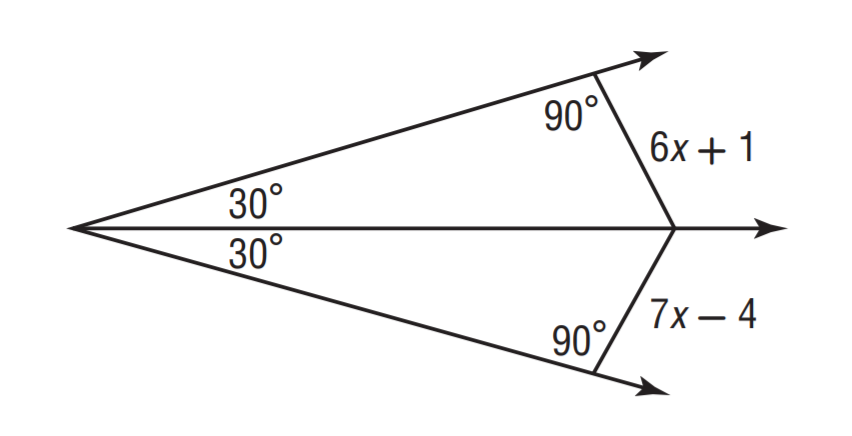Question: Solve for x.
Choices:
A. 3
B. 4
C. 5
D. 6
Answer with the letter. Answer: C 